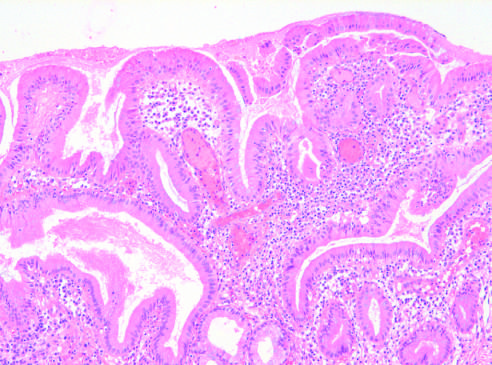what is infiltrated by chronic inflammatory cells?
Answer the question using a single word or phrase. The gallbladder mucosa 